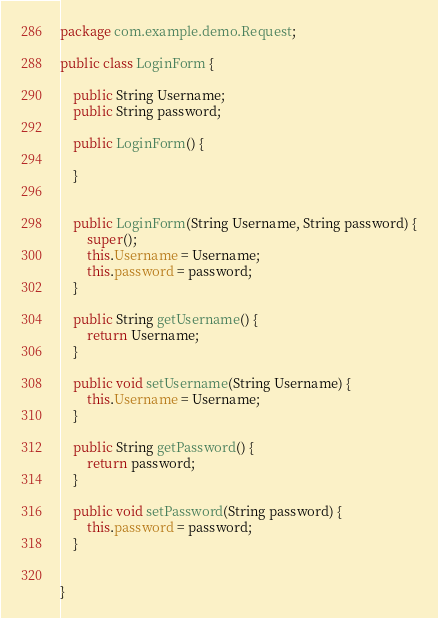Convert code to text. <code><loc_0><loc_0><loc_500><loc_500><_Java_>package com.example.demo.Request;

public class LoginForm {

    public String Username;
    public String password;

    public LoginForm() {

    }


    public LoginForm(String Username, String password) {
        super();
        this.Username = Username;
        this.password = password;
    }

    public String getUsername() {
        return Username;
    }

    public void setUsername(String Username) {
        this.Username = Username;
    }

    public String getPassword() {
        return password;
    }

    public void setPassword(String password) {
        this.password = password;
    }


}
</code> 